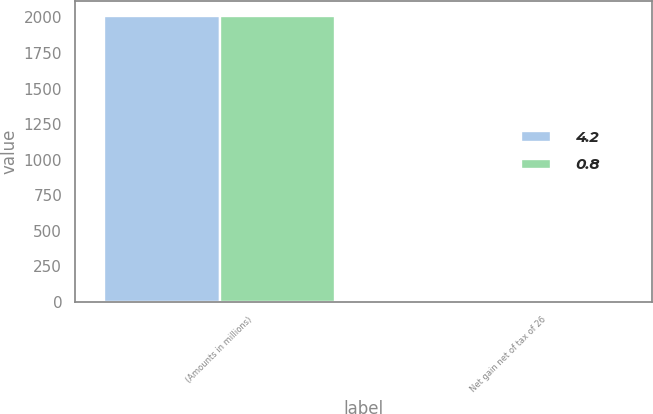<chart> <loc_0><loc_0><loc_500><loc_500><stacked_bar_chart><ecel><fcel>(Amounts in millions)<fcel>Net gain net of tax of 26<nl><fcel>4.2<fcel>2013<fcel>4.2<nl><fcel>0.8<fcel>2012<fcel>0.8<nl></chart> 